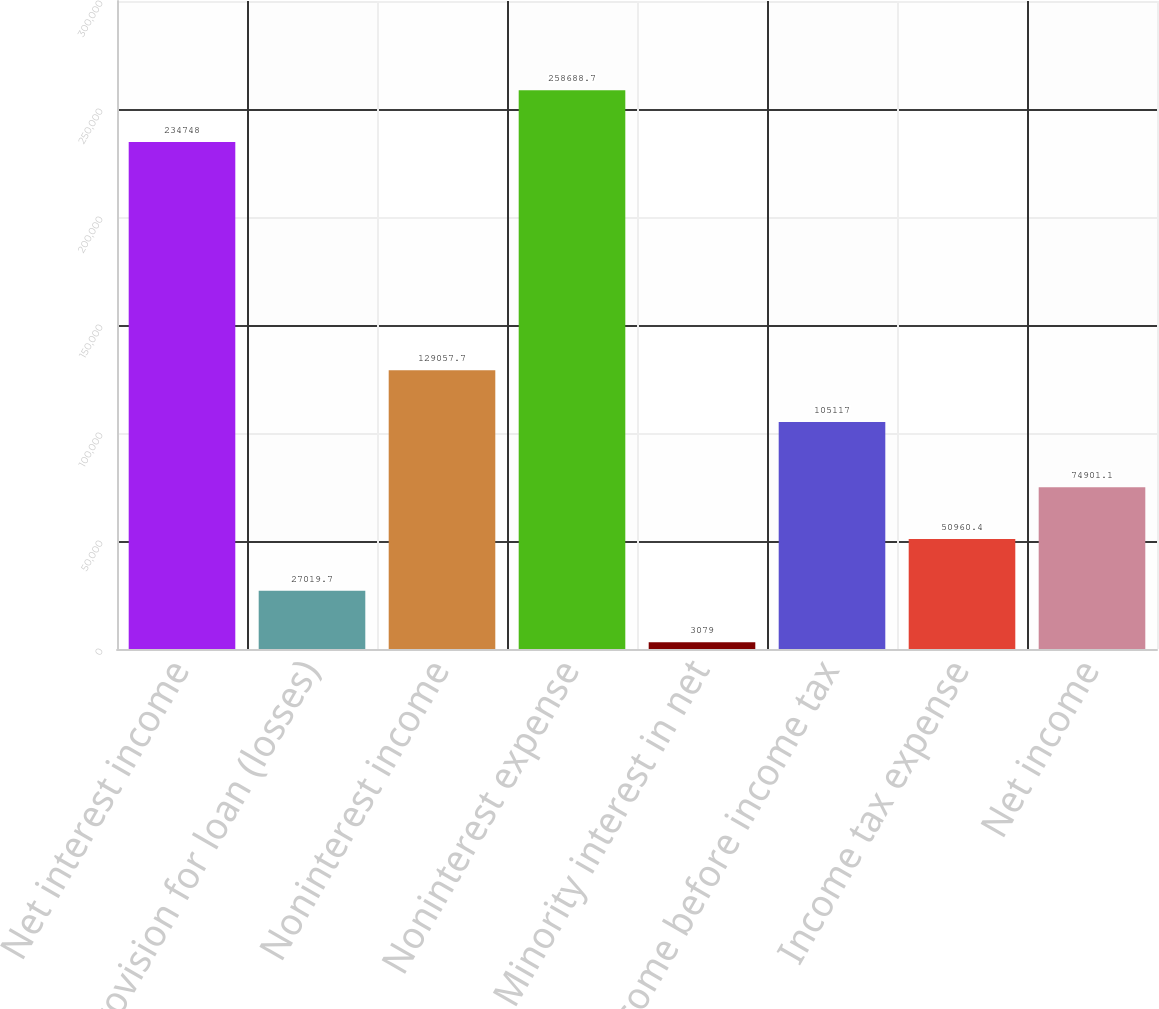Convert chart to OTSL. <chart><loc_0><loc_0><loc_500><loc_500><bar_chart><fcel>Net interest income<fcel>Provision for loan (losses)<fcel>Noninterest income<fcel>Noninterest expense<fcel>Minority interest in net<fcel>Income before income tax<fcel>Income tax expense<fcel>Net income<nl><fcel>234748<fcel>27019.7<fcel>129058<fcel>258689<fcel>3079<fcel>105117<fcel>50960.4<fcel>74901.1<nl></chart> 